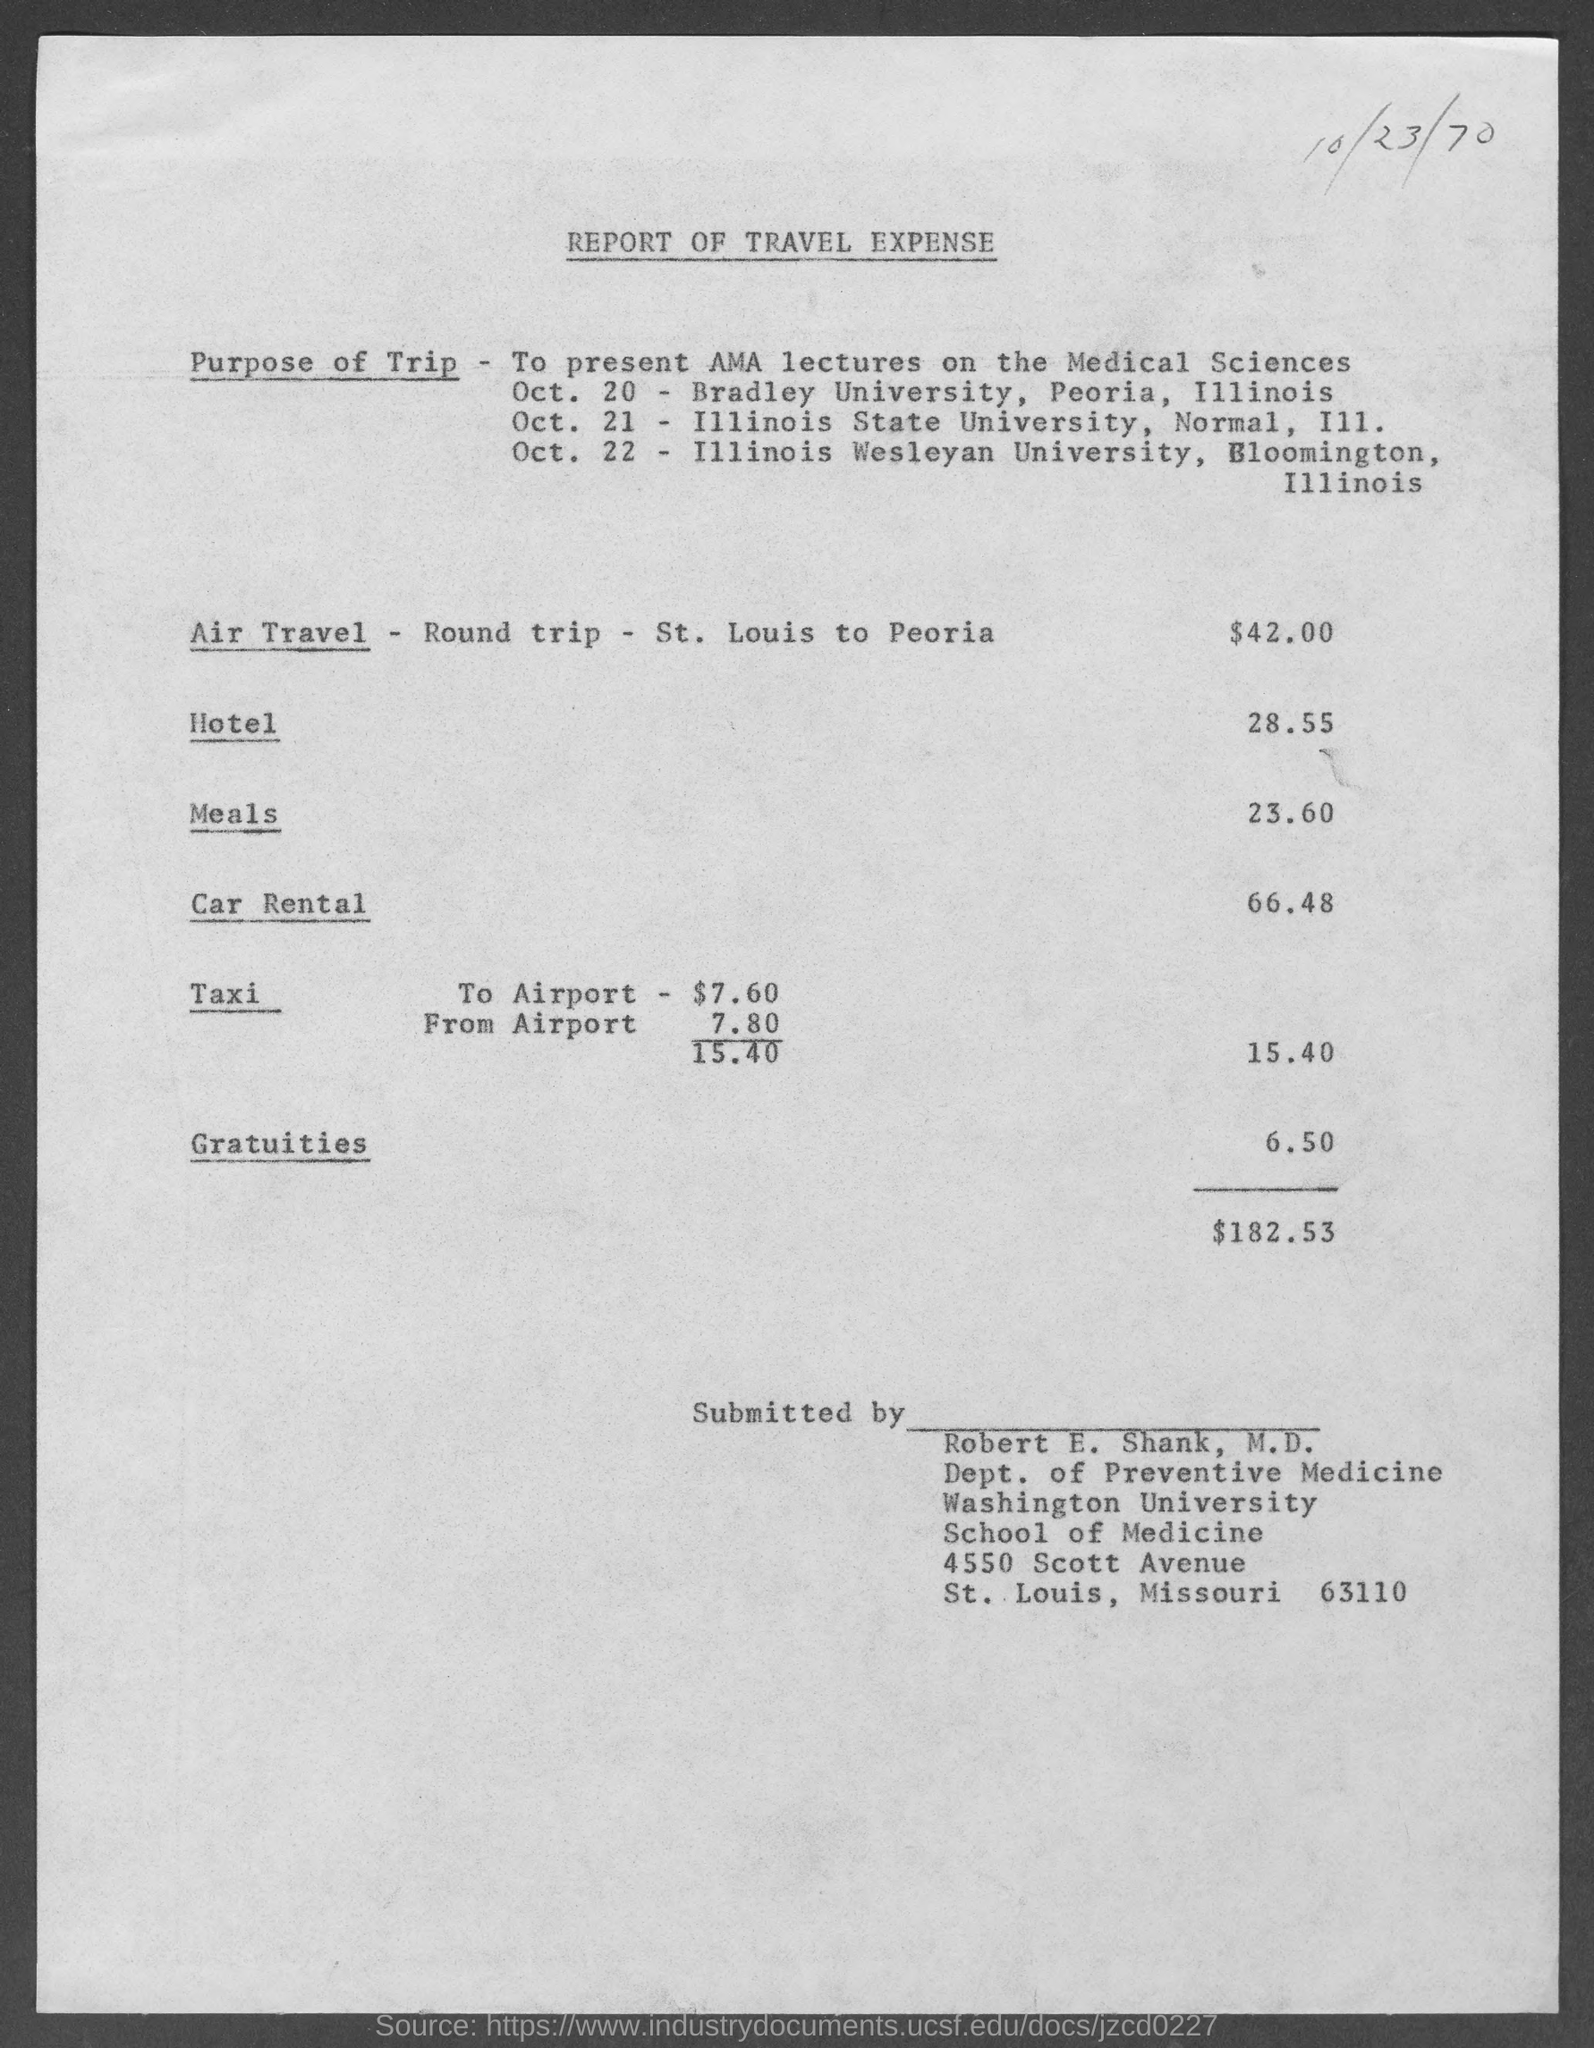Outline some significant characteristics in this image. The amount for gratuities mentioned in the given report is 50. The expenses for taxi as mentioned in the given report are 15 and 40. The date mentioned in the provided report is 10/23/70. The amount for car rental mentioned in the given report is 66.48 dollars. The total expenses mentioned in the given report are $182.53. 